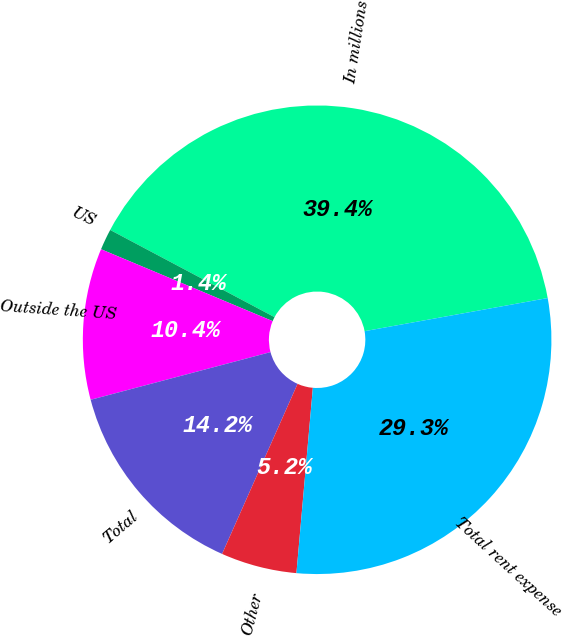Convert chart. <chart><loc_0><loc_0><loc_500><loc_500><pie_chart><fcel>In millions<fcel>US<fcel>Outside the US<fcel>Total<fcel>Other<fcel>Total rent expense<nl><fcel>39.39%<fcel>1.45%<fcel>10.44%<fcel>14.23%<fcel>5.24%<fcel>29.26%<nl></chart> 